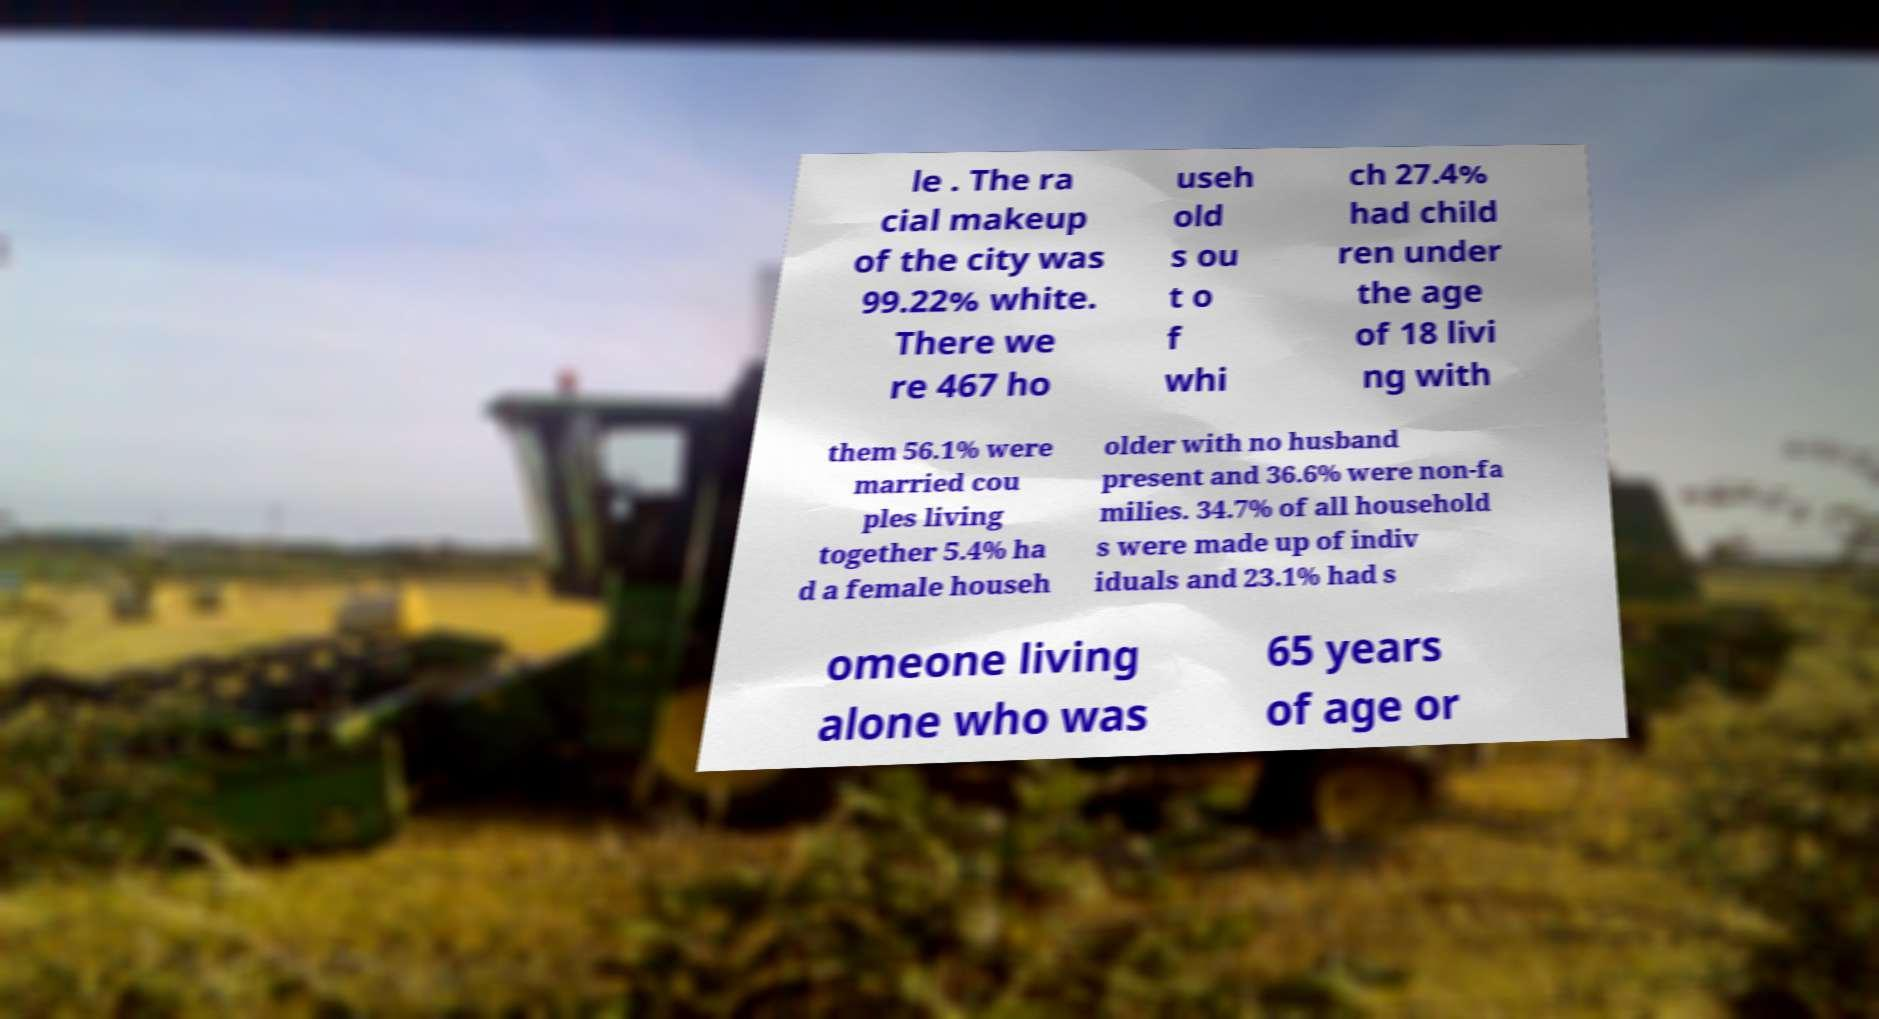Can you accurately transcribe the text from the provided image for me? le . The ra cial makeup of the city was 99.22% white. There we re 467 ho useh old s ou t o f whi ch 27.4% had child ren under the age of 18 livi ng with them 56.1% were married cou ples living together 5.4% ha d a female househ older with no husband present and 36.6% were non-fa milies. 34.7% of all household s were made up of indiv iduals and 23.1% had s omeone living alone who was 65 years of age or 